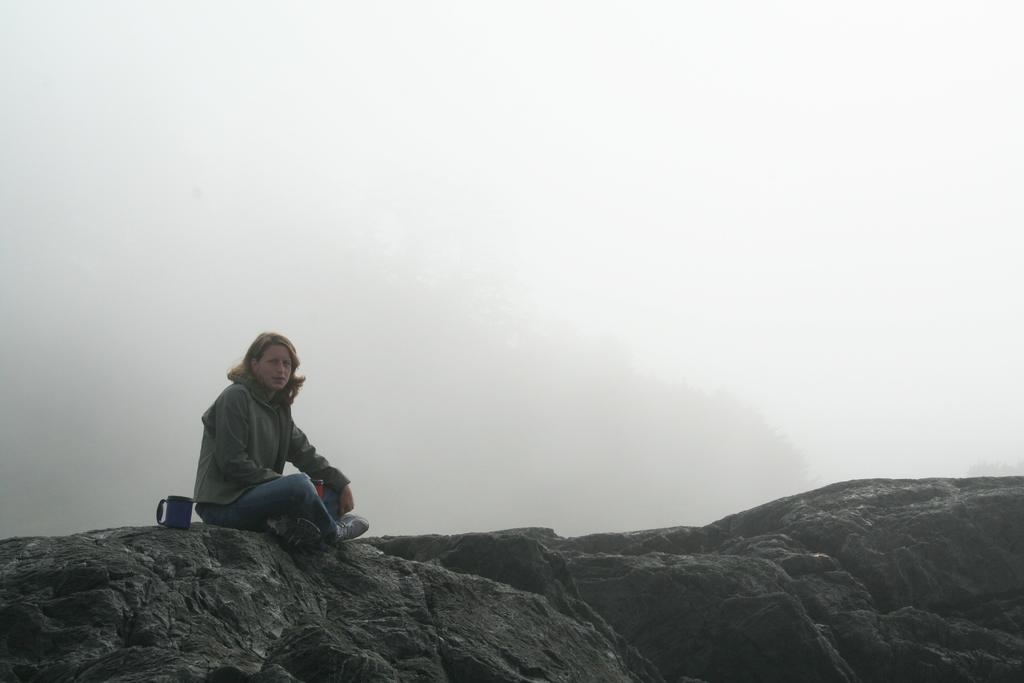Who is present in the image? There is a woman in the image. What is the woman sitting on? The woman is sitting on a rock surface. What object is beside the woman? There is a mug beside the woman. What other rock surface can be seen in the image? There is another rock surface visible in the image. What can be seen in the background of the image? The sky is visible in the background of the image. What type of flesh can be seen on the woman's face in the image? There is no flesh visible on the woman's face in the image; it is a photograph, not a painting or drawing. 